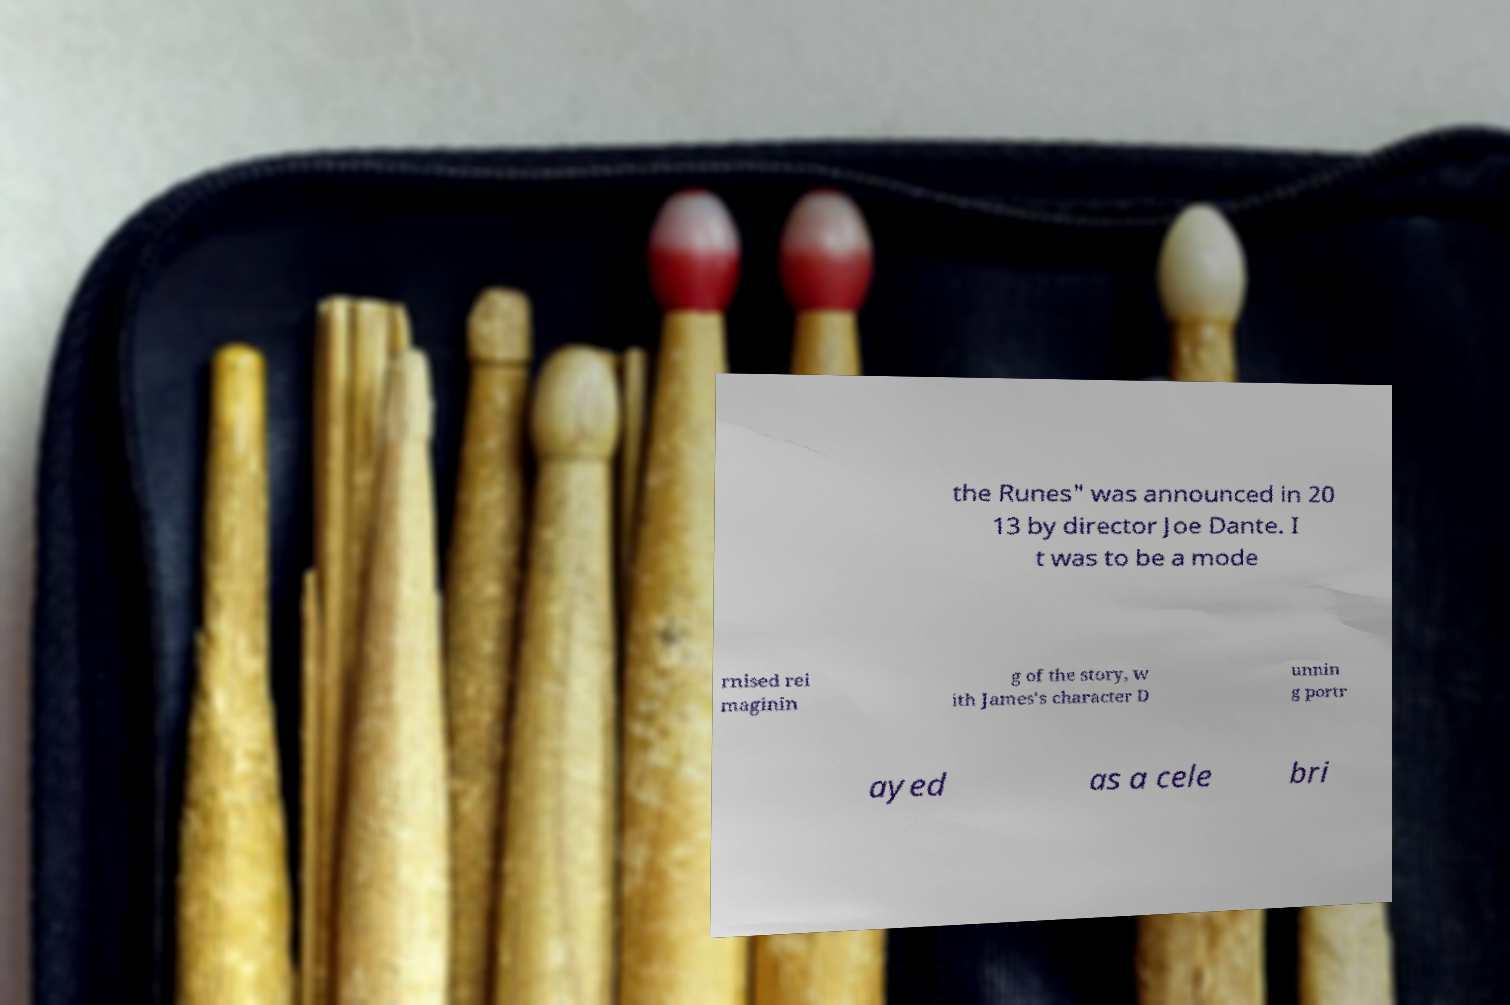For documentation purposes, I need the text within this image transcribed. Could you provide that? the Runes" was announced in 20 13 by director Joe Dante. I t was to be a mode rnised rei maginin g of the story, w ith James's character D unnin g portr ayed as a cele bri 